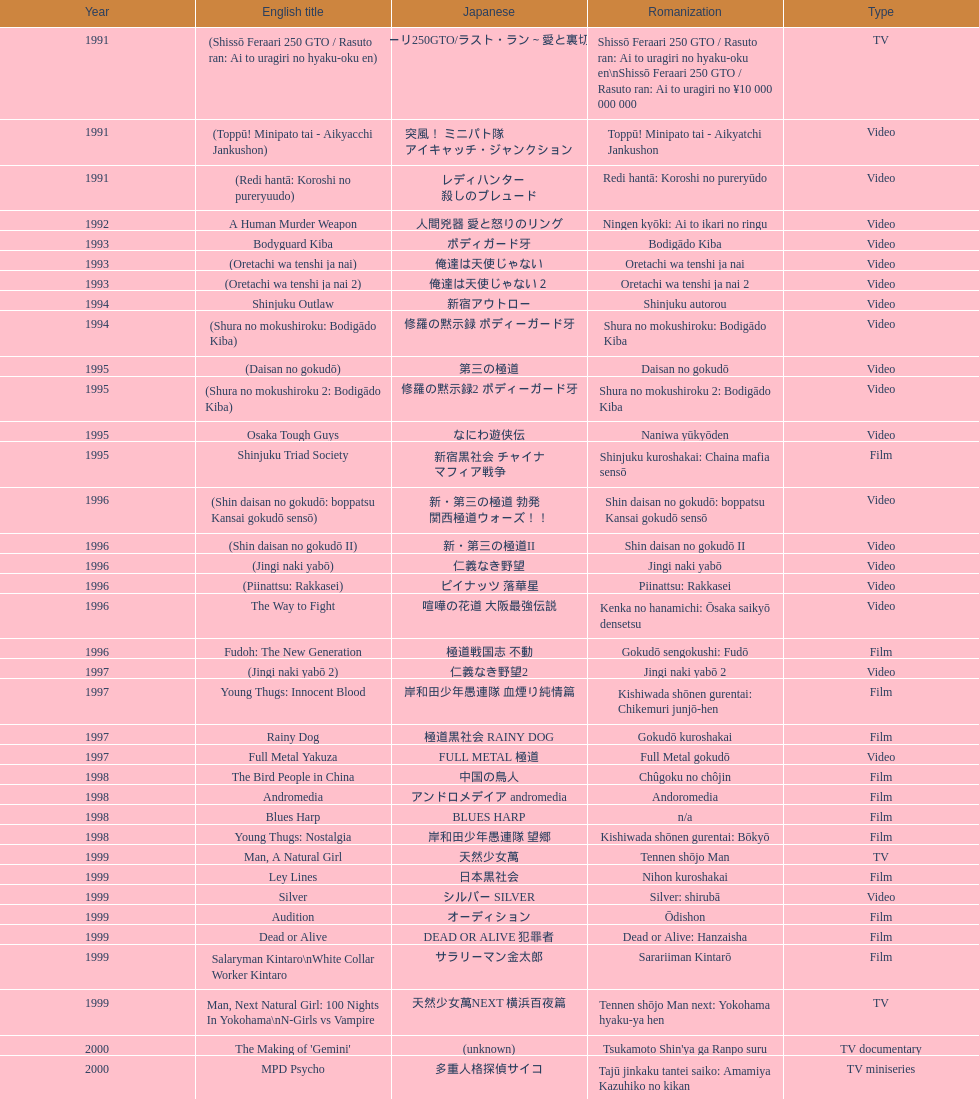Was shinjuku triad society released as a cinema or television production? Film. 